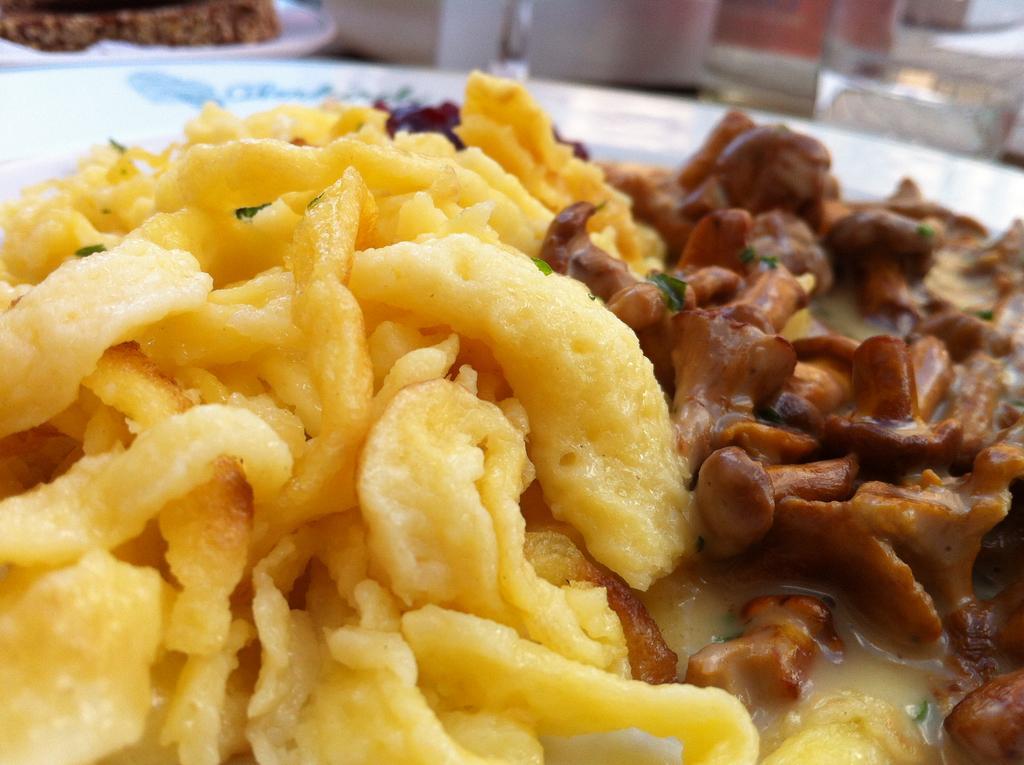Can you describe this image briefly? In this picture we can see plates with food items on it, glass with water in it and some objects. 